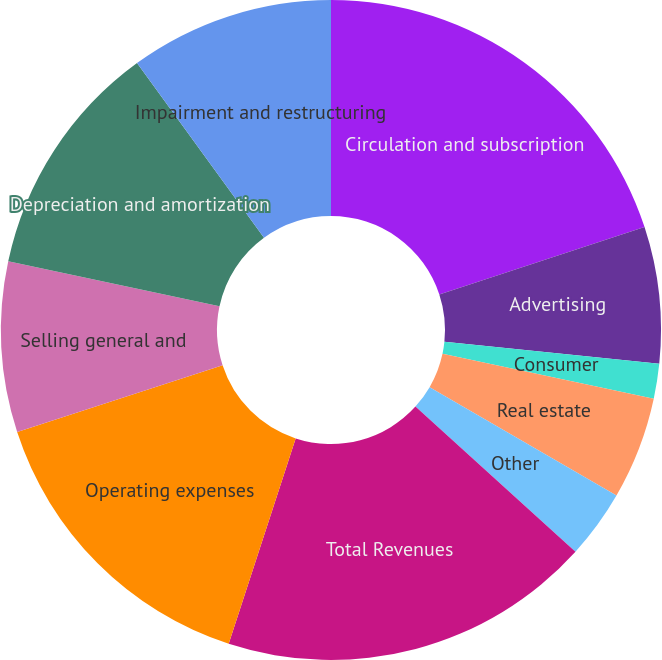<chart> <loc_0><loc_0><loc_500><loc_500><pie_chart><fcel>Circulation and subscription<fcel>Advertising<fcel>Consumer<fcel>Real estate<fcel>Other<fcel>Total Revenues<fcel>Operating expenses<fcel>Selling general and<fcel>Depreciation and amortization<fcel>Impairment and restructuring<nl><fcel>19.95%<fcel>6.68%<fcel>1.71%<fcel>5.02%<fcel>3.36%<fcel>18.29%<fcel>14.98%<fcel>8.34%<fcel>11.66%<fcel>10.0%<nl></chart> 